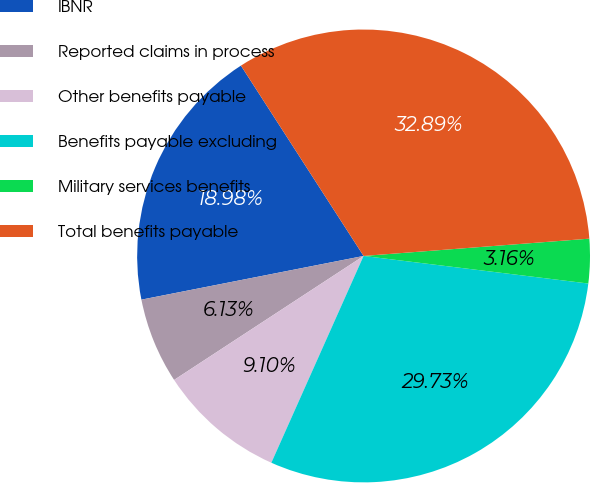<chart> <loc_0><loc_0><loc_500><loc_500><pie_chart><fcel>IBNR<fcel>Reported claims in process<fcel>Other benefits payable<fcel>Benefits payable excluding<fcel>Military services benefits<fcel>Total benefits payable<nl><fcel>18.98%<fcel>6.13%<fcel>9.1%<fcel>29.73%<fcel>3.16%<fcel>32.89%<nl></chart> 